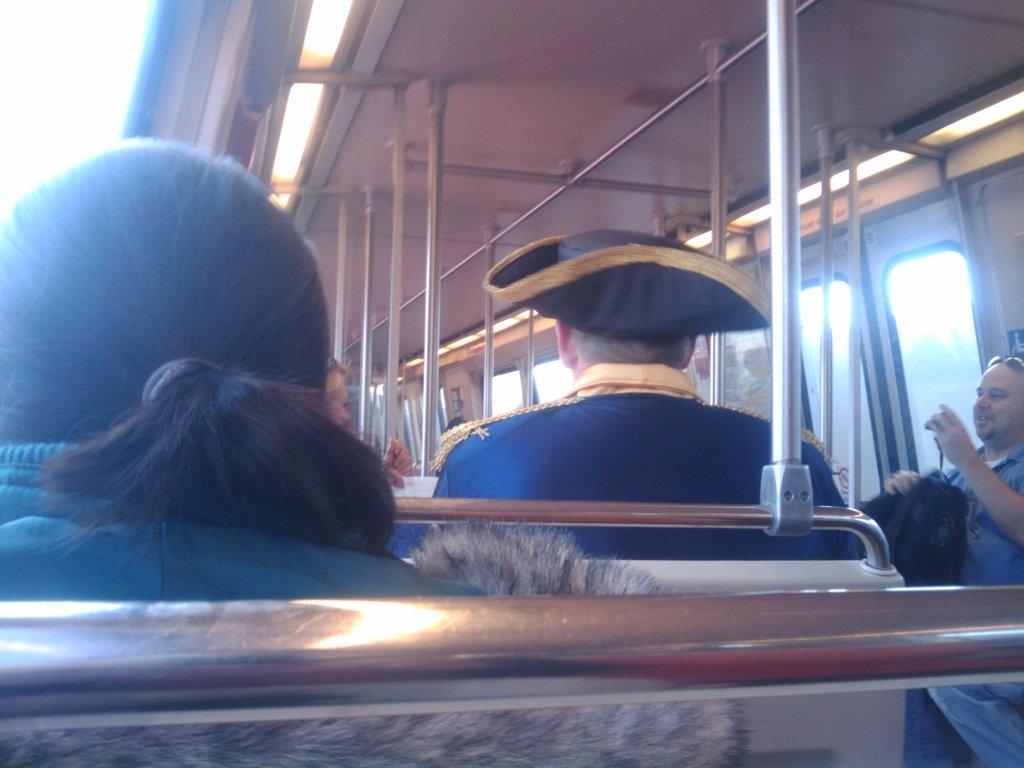What are the people in the image doing? The people in the image are sitting in a bus. What can be seen on the top of the bus? There are rods and a sheet on the top of the bus. What features can be observed on the bus? There are lights visible on the bus. How many eggs are being transported by the bus in the image? There is no indication of eggs being transported in the image; the focus is on the people sitting in the bus and the features of the bus itself. 